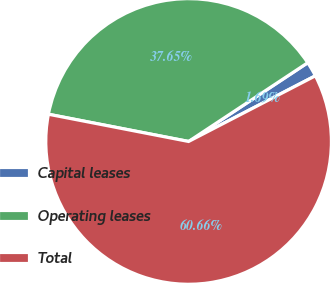Convert chart to OTSL. <chart><loc_0><loc_0><loc_500><loc_500><pie_chart><fcel>Capital leases<fcel>Operating leases<fcel>Total<nl><fcel>1.69%<fcel>37.65%<fcel>60.66%<nl></chart> 